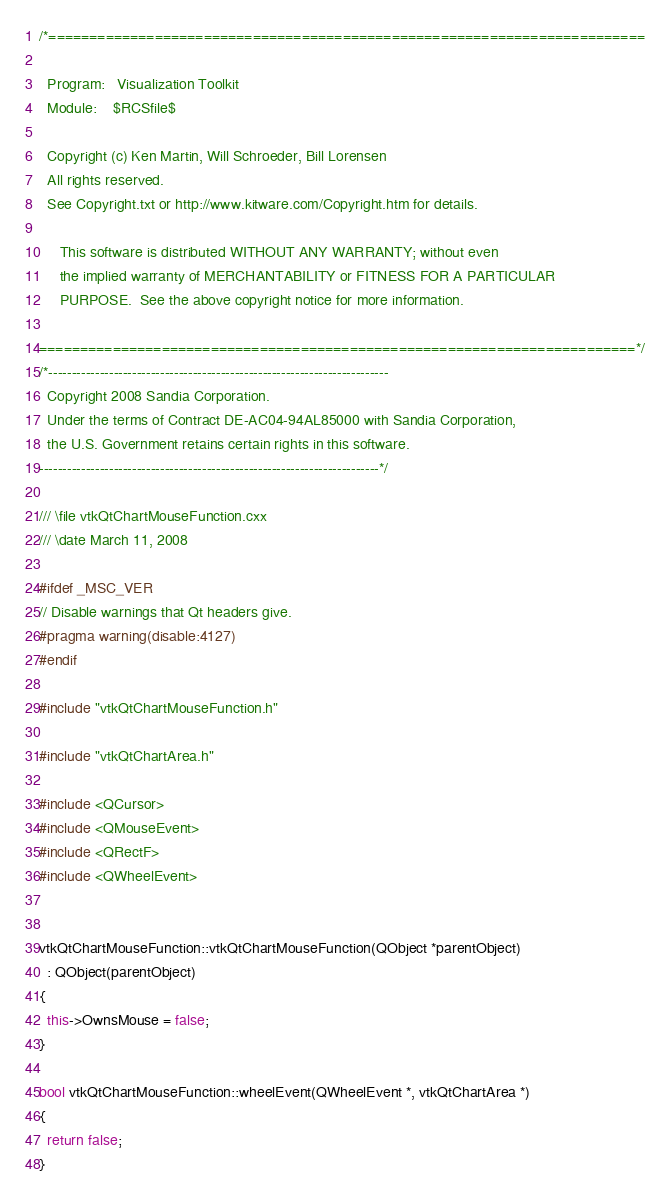Convert code to text. <code><loc_0><loc_0><loc_500><loc_500><_C++_>/*=========================================================================

  Program:   Visualization Toolkit
  Module:    $RCSfile$

  Copyright (c) Ken Martin, Will Schroeder, Bill Lorensen
  All rights reserved.
  See Copyright.txt or http://www.kitware.com/Copyright.htm for details.

     This software is distributed WITHOUT ANY WARRANTY; without even
     the implied warranty of MERCHANTABILITY or FITNESS FOR A PARTICULAR
     PURPOSE.  See the above copyright notice for more information.

=========================================================================*/
/*-------------------------------------------------------------------------
  Copyright 2008 Sandia Corporation.
  Under the terms of Contract DE-AC04-94AL85000 with Sandia Corporation,
  the U.S. Government retains certain rights in this software.
-------------------------------------------------------------------------*/

/// \file vtkQtChartMouseFunction.cxx
/// \date March 11, 2008

#ifdef _MSC_VER
// Disable warnings that Qt headers give.
#pragma warning(disable:4127)
#endif

#include "vtkQtChartMouseFunction.h"

#include "vtkQtChartArea.h"

#include <QCursor>
#include <QMouseEvent>
#include <QRectF>
#include <QWheelEvent>


vtkQtChartMouseFunction::vtkQtChartMouseFunction(QObject *parentObject)
  : QObject(parentObject)
{
  this->OwnsMouse = false;
}

bool vtkQtChartMouseFunction::wheelEvent(QWheelEvent *, vtkQtChartArea *)
{
  return false;
}


</code> 